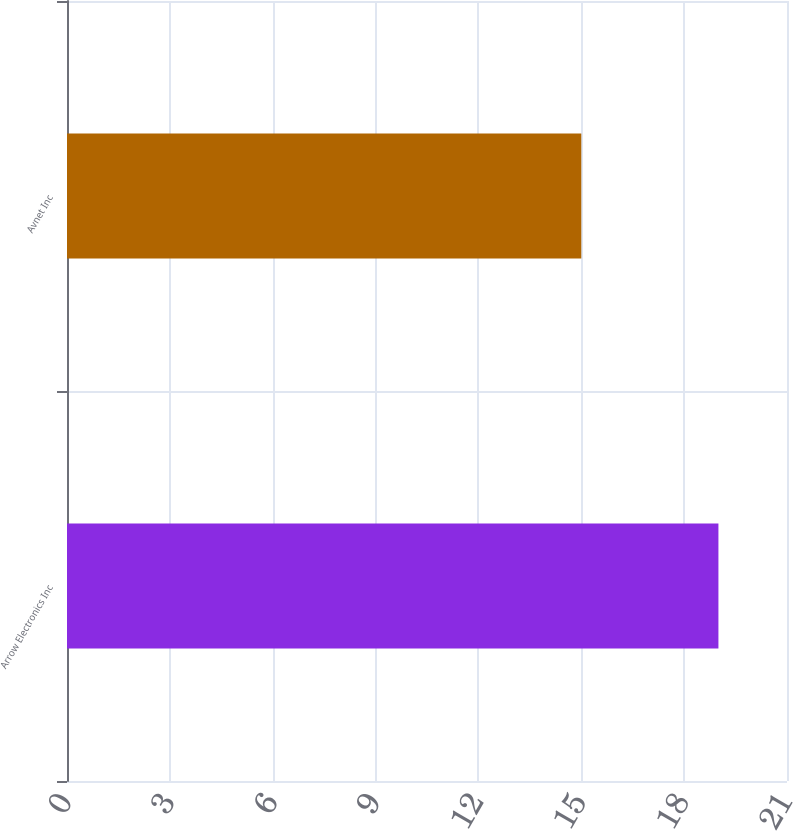Convert chart. <chart><loc_0><loc_0><loc_500><loc_500><bar_chart><fcel>Arrow Electronics Inc<fcel>Avnet Inc<nl><fcel>19<fcel>15<nl></chart> 